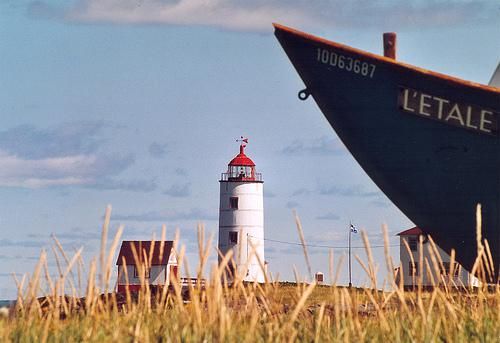Question: how does the grass appear?
Choices:
A. Burned.
B. Dry.
C. Wet.
D. Choppy.
Answer with the letter. Answer: B Question: how many flags in the photo?
Choices:
A. Two.
B. Three.
C. One.
D. Four.
Answer with the letter. Answer: C Question: where does the sky look?
Choices:
A. Sunny.
B. Eastward.
C. Rainy.
D. Cloudy.
Answer with the letter. Answer: A Question: where is the ship?
Choices:
A. On the right.
B. To the left side.
C. At the dock.
D. At the port.
Answer with the letter. Answer: A Question: what color is the lighthouse?
Choices:
A. Blue and yellow.
B. Light green.
C. Black and red.
D. Red and White.
Answer with the letter. Answer: D 